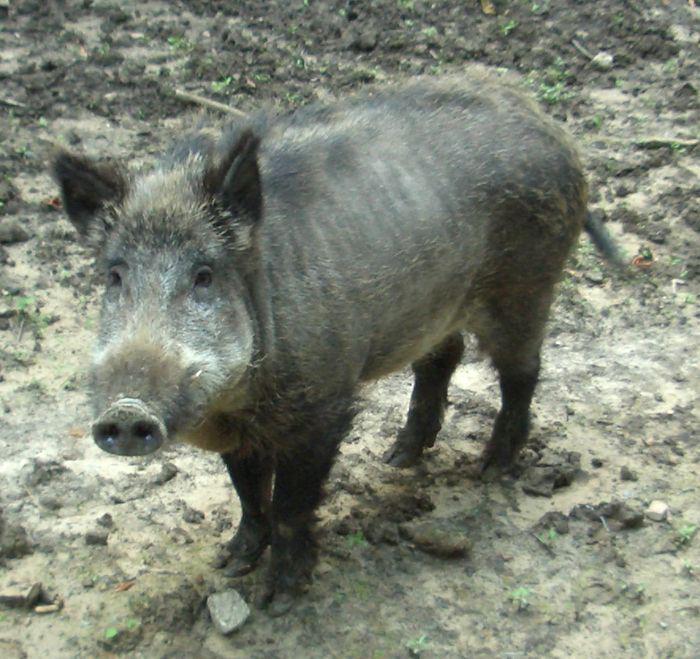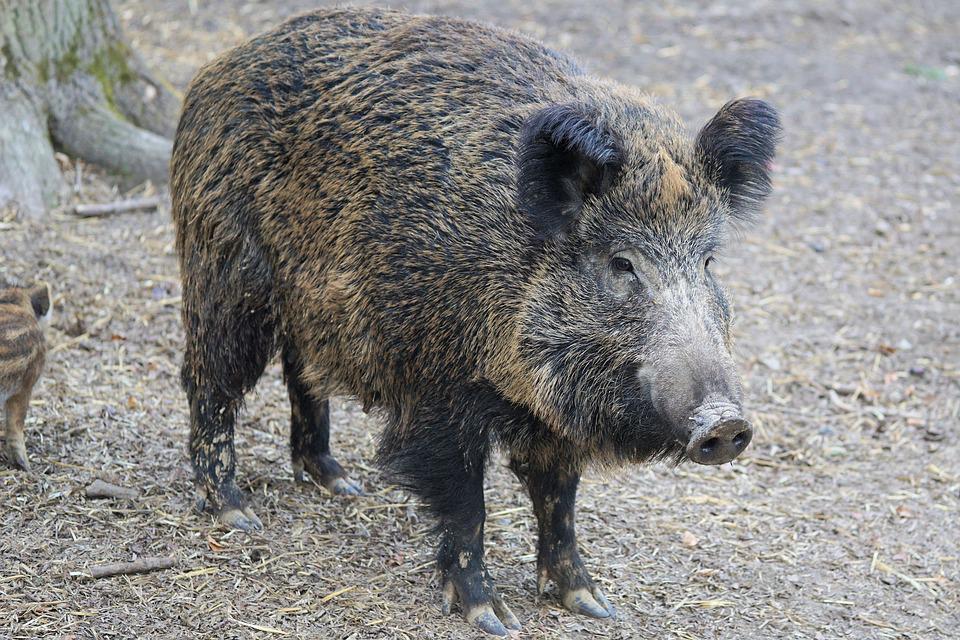The first image is the image on the left, the second image is the image on the right. Examine the images to the left and right. Is the description "The hogs in the pair of images face opposite directions." accurate? Answer yes or no. Yes. 